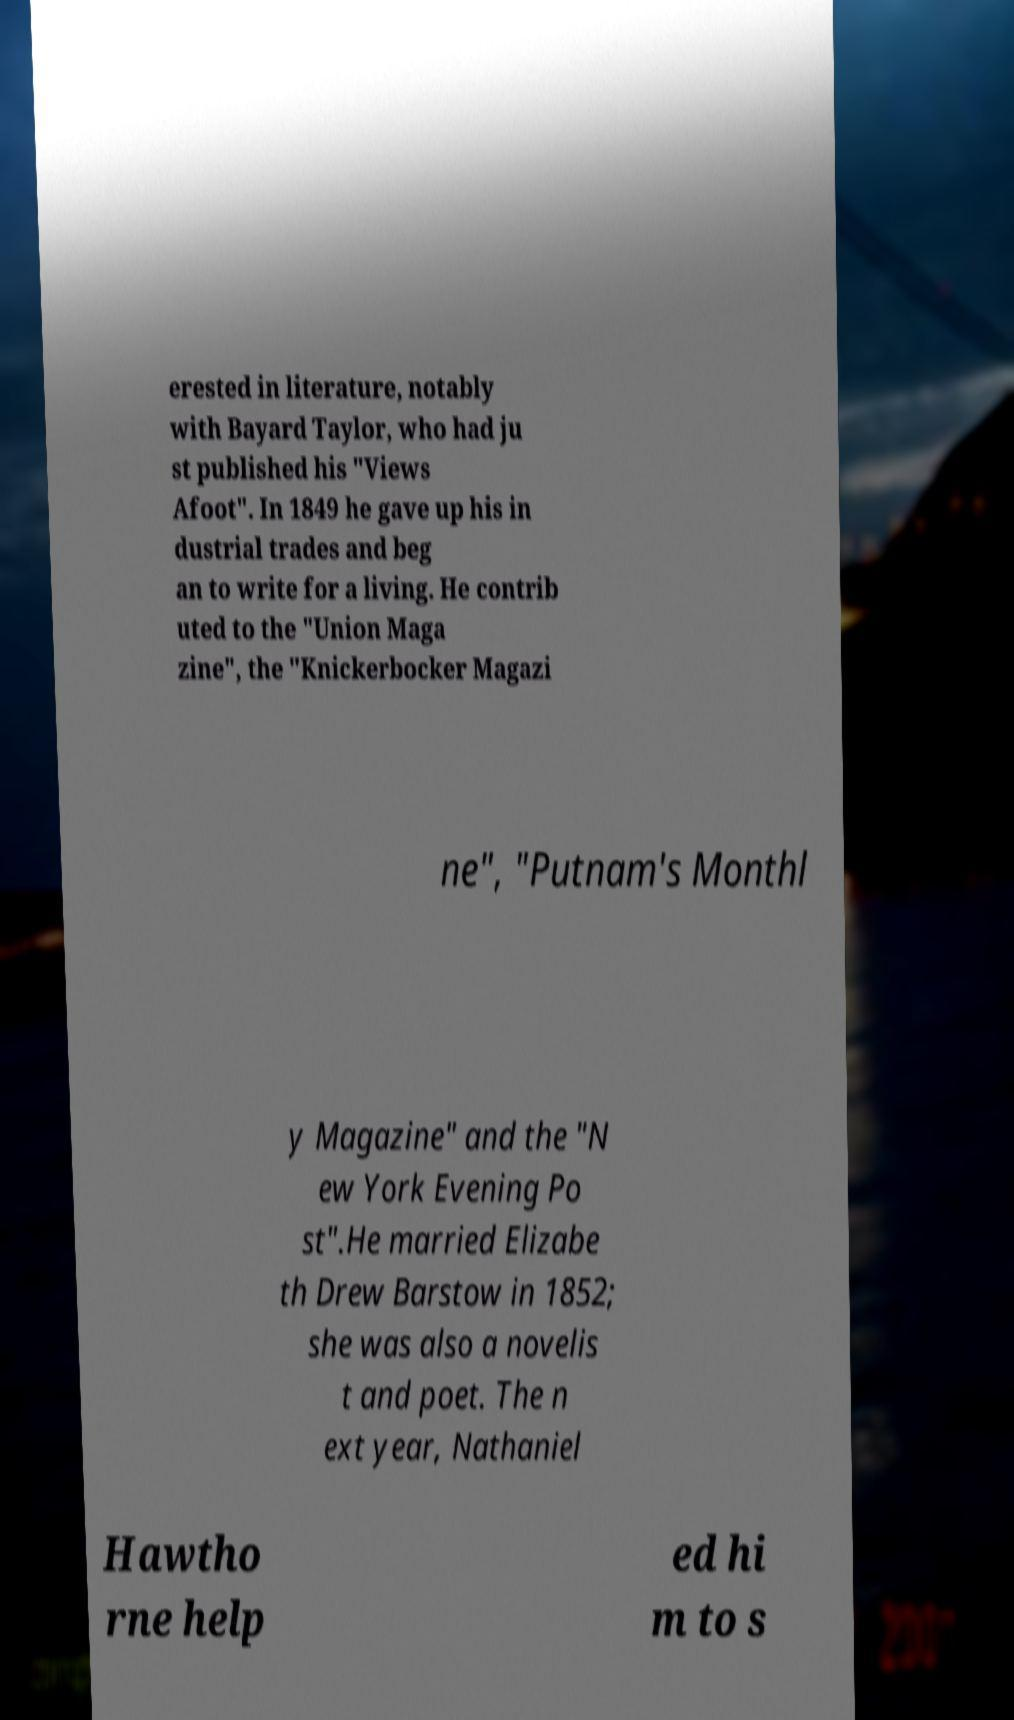Can you accurately transcribe the text from the provided image for me? erested in literature, notably with Bayard Taylor, who had ju st published his "Views Afoot". In 1849 he gave up his in dustrial trades and beg an to write for a living. He contrib uted to the "Union Maga zine", the "Knickerbocker Magazi ne", "Putnam's Monthl y Magazine" and the "N ew York Evening Po st".He married Elizabe th Drew Barstow in 1852; she was also a novelis t and poet. The n ext year, Nathaniel Hawtho rne help ed hi m to s 